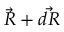Convert formula to latex. <formula><loc_0><loc_0><loc_500><loc_500>{ \vec { R } } + { \vec { d R } }</formula> 